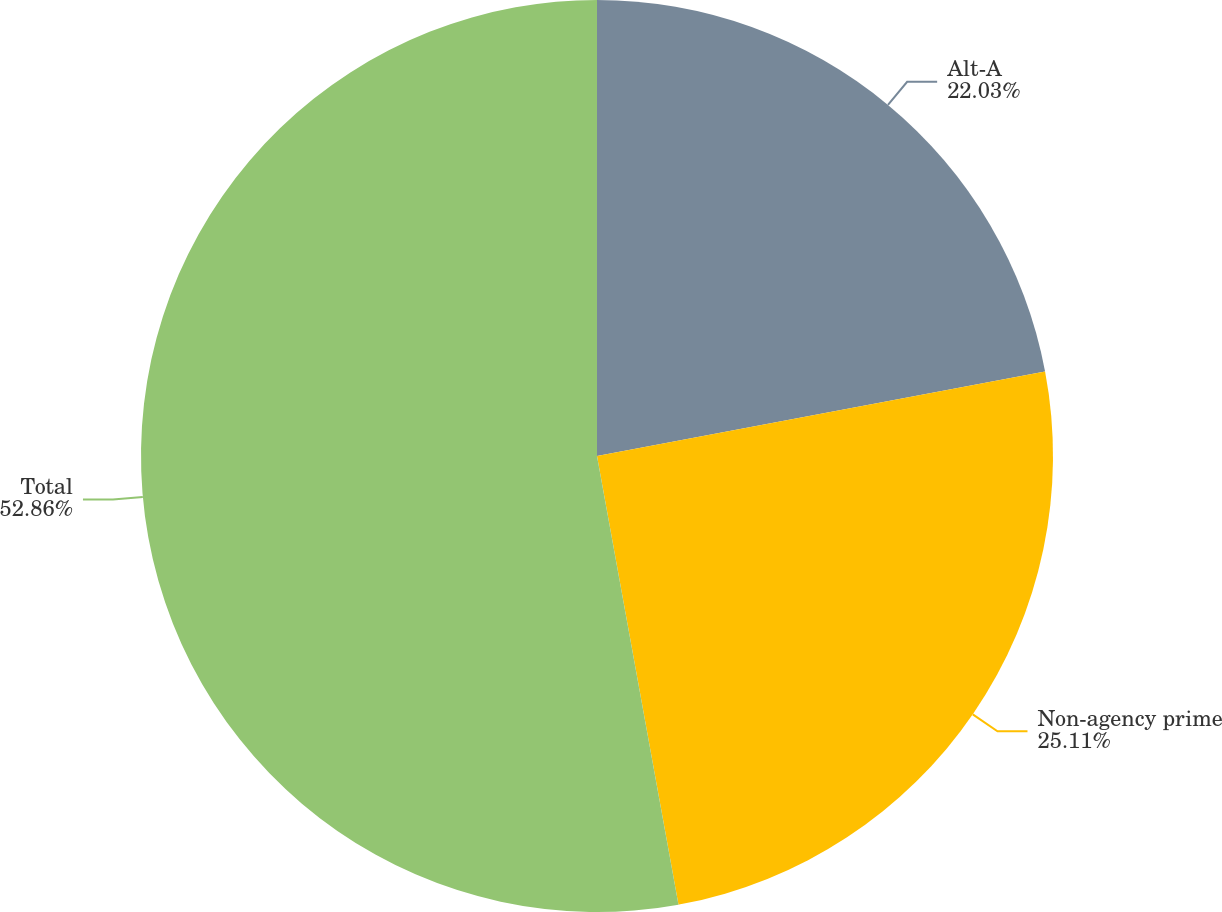<chart> <loc_0><loc_0><loc_500><loc_500><pie_chart><fcel>Alt-A<fcel>Non-agency prime<fcel>Total<nl><fcel>22.03%<fcel>25.11%<fcel>52.86%<nl></chart> 